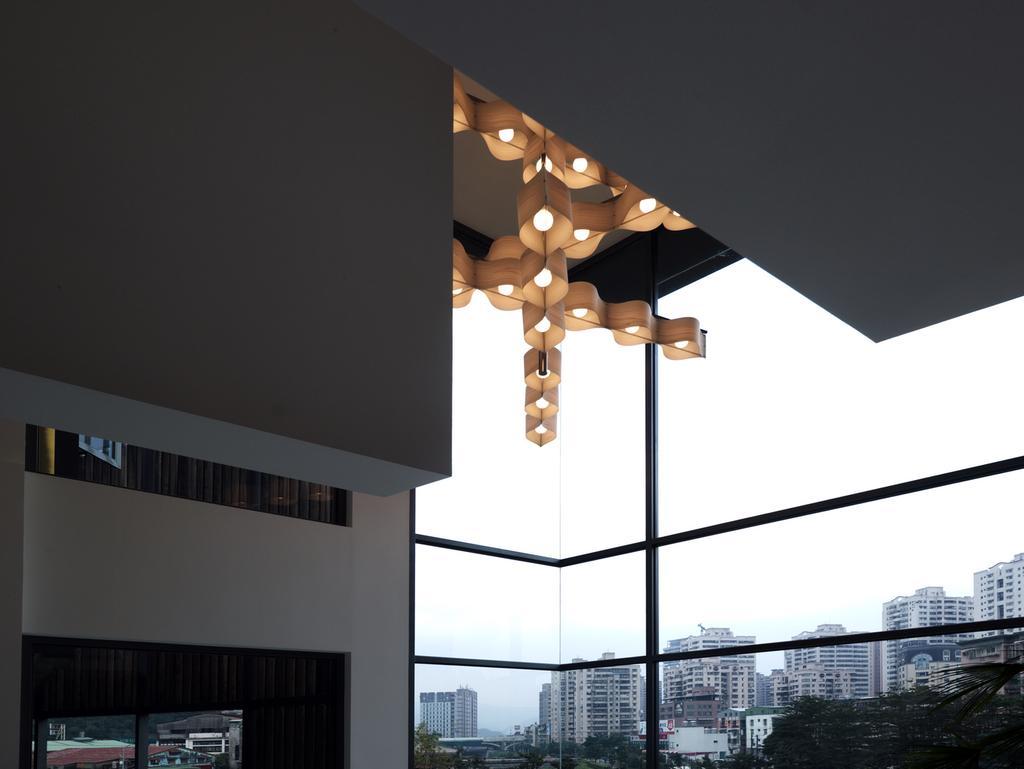Could you give a brief overview of what you see in this image? This image is clicked from inside the building. In this image there is a glass through which we can see the buildings and trees. At the top there are lights. On the left side there is a wall. At the bottom there is a window on the left side. 